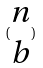<formula> <loc_0><loc_0><loc_500><loc_500>( \begin{matrix} n \\ b \end{matrix} )</formula> 